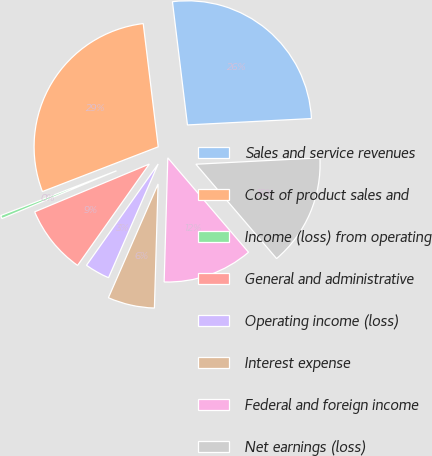Convert chart. <chart><loc_0><loc_0><loc_500><loc_500><pie_chart><fcel>Sales and service revenues<fcel>Cost of product sales and<fcel>Income (loss) from operating<fcel>General and administrative<fcel>Operating income (loss)<fcel>Interest expense<fcel>Federal and foreign income<fcel>Net earnings (loss)<nl><fcel>26.11%<fcel>28.94%<fcel>0.42%<fcel>8.91%<fcel>3.25%<fcel>6.08%<fcel>11.73%<fcel>14.56%<nl></chart> 